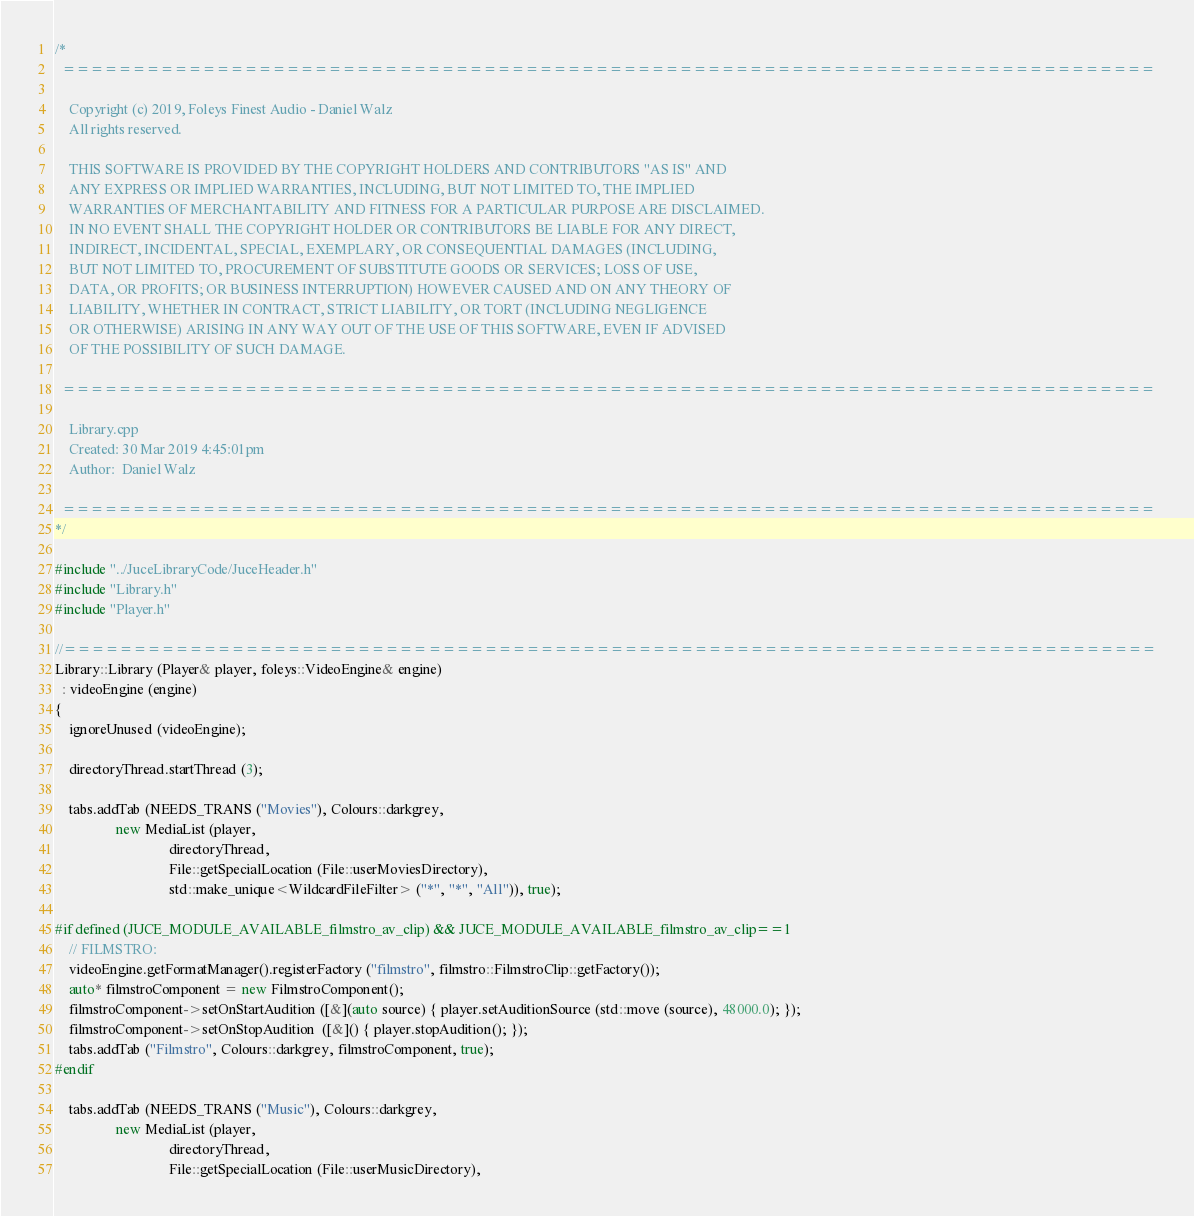<code> <loc_0><loc_0><loc_500><loc_500><_C++_>/*
  ==============================================================================

    Copyright (c) 2019, Foleys Finest Audio - Daniel Walz
    All rights reserved.

    THIS SOFTWARE IS PROVIDED BY THE COPYRIGHT HOLDERS AND CONTRIBUTORS "AS IS" AND
    ANY EXPRESS OR IMPLIED WARRANTIES, INCLUDING, BUT NOT LIMITED TO, THE IMPLIED
    WARRANTIES OF MERCHANTABILITY AND FITNESS FOR A PARTICULAR PURPOSE ARE DISCLAIMED.
    IN NO EVENT SHALL THE COPYRIGHT HOLDER OR CONTRIBUTORS BE LIABLE FOR ANY DIRECT,
    INDIRECT, INCIDENTAL, SPECIAL, EXEMPLARY, OR CONSEQUENTIAL DAMAGES (INCLUDING,
    BUT NOT LIMITED TO, PROCUREMENT OF SUBSTITUTE GOODS OR SERVICES; LOSS OF USE,
    DATA, OR PROFITS; OR BUSINESS INTERRUPTION) HOWEVER CAUSED AND ON ANY THEORY OF
    LIABILITY, WHETHER IN CONTRACT, STRICT LIABILITY, OR TORT (INCLUDING NEGLIGENCE
    OR OTHERWISE) ARISING IN ANY WAY OUT OF THE USE OF THIS SOFTWARE, EVEN IF ADVISED
    OF THE POSSIBILITY OF SUCH DAMAGE.

  ==============================================================================

    Library.cpp
    Created: 30 Mar 2019 4:45:01pm
    Author:  Daniel Walz

  ==============================================================================
*/

#include "../JuceLibraryCode/JuceHeader.h"
#include "Library.h"
#include "Player.h"

//==============================================================================
Library::Library (Player& player, foleys::VideoEngine& engine)
  : videoEngine (engine)
{
    ignoreUnused (videoEngine);

    directoryThread.startThread (3);

    tabs.addTab (NEEDS_TRANS ("Movies"), Colours::darkgrey,
                 new MediaList (player,
                                directoryThread,
                                File::getSpecialLocation (File::userMoviesDirectory),
                                std::make_unique<WildcardFileFilter> ("*", "*", "All")), true);

#if defined (JUCE_MODULE_AVAILABLE_filmstro_av_clip) && JUCE_MODULE_AVAILABLE_filmstro_av_clip==1
    // FILMSTRO:
    videoEngine.getFormatManager().registerFactory ("filmstro", filmstro::FilmstroClip::getFactory());
    auto* filmstroComponent = new FilmstroComponent();
    filmstroComponent->setOnStartAudition ([&](auto source) { player.setAuditionSource (std::move (source), 48000.0); });
    filmstroComponent->setOnStopAudition  ([&]() { player.stopAudition(); });
    tabs.addTab ("Filmstro", Colours::darkgrey, filmstroComponent, true);
#endif

    tabs.addTab (NEEDS_TRANS ("Music"), Colours::darkgrey,
                 new MediaList (player,
                                directoryThread,
                                File::getSpecialLocation (File::userMusicDirectory),</code> 